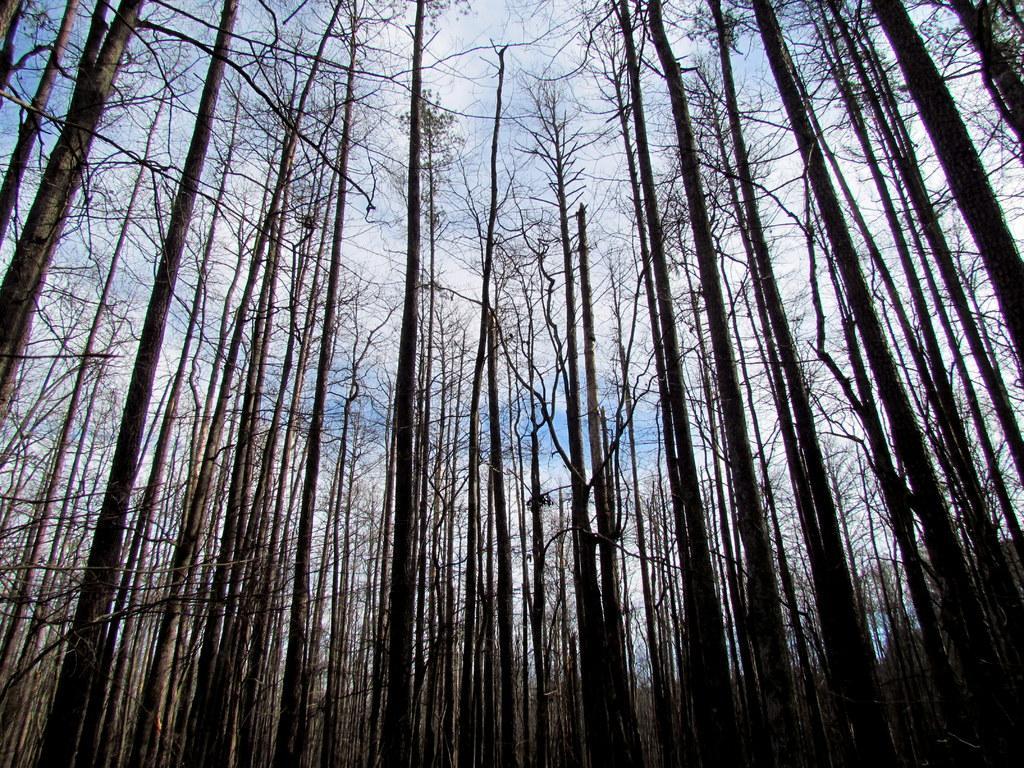In one or two sentences, can you explain what this image depicts? In this picture we can see few trees and clouds. 